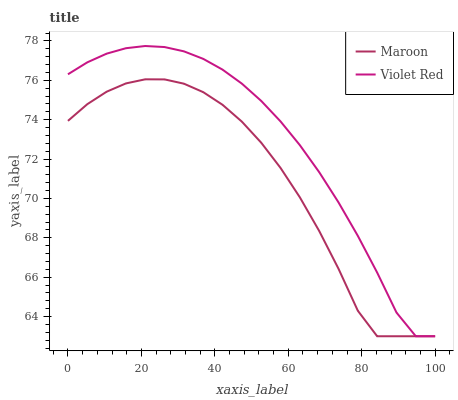Does Maroon have the minimum area under the curve?
Answer yes or no. Yes. Does Violet Red have the maximum area under the curve?
Answer yes or no. Yes. Does Maroon have the maximum area under the curve?
Answer yes or no. No. Is Violet Red the smoothest?
Answer yes or no. Yes. Is Maroon the roughest?
Answer yes or no. Yes. Is Maroon the smoothest?
Answer yes or no. No. Does Maroon have the highest value?
Answer yes or no. No. 